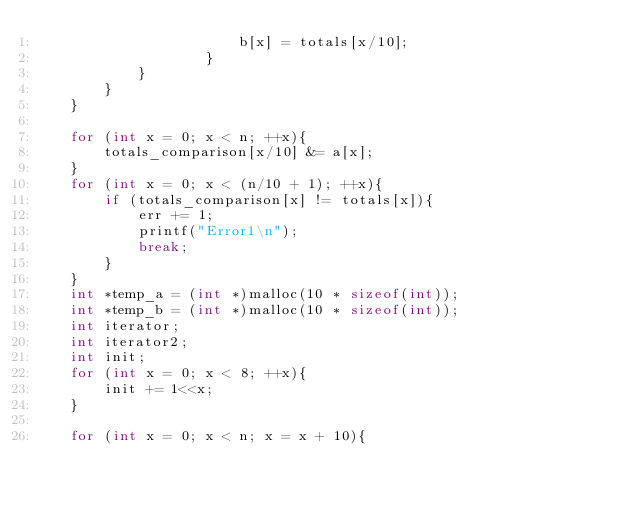<code> <loc_0><loc_0><loc_500><loc_500><_C_>                        b[x] = totals[x/10];
                    }
            }
        }
    }

    for (int x = 0; x < n; ++x){
        totals_comparison[x/10] &= a[x];
    }
    for (int x = 0; x < (n/10 + 1); ++x){
        if (totals_comparison[x] != totals[x]){
            err += 1;
            printf("Error1\n");
            break;
        }
    }
    int *temp_a = (int *)malloc(10 * sizeof(int));
    int *temp_b = (int *)malloc(10 * sizeof(int));
    int iterator;
    int iterator2;
    int init;
    for (int x = 0; x < 8; ++x){
        init += 1<<x;
    }

    for (int x = 0; x < n; x = x + 10){</code> 